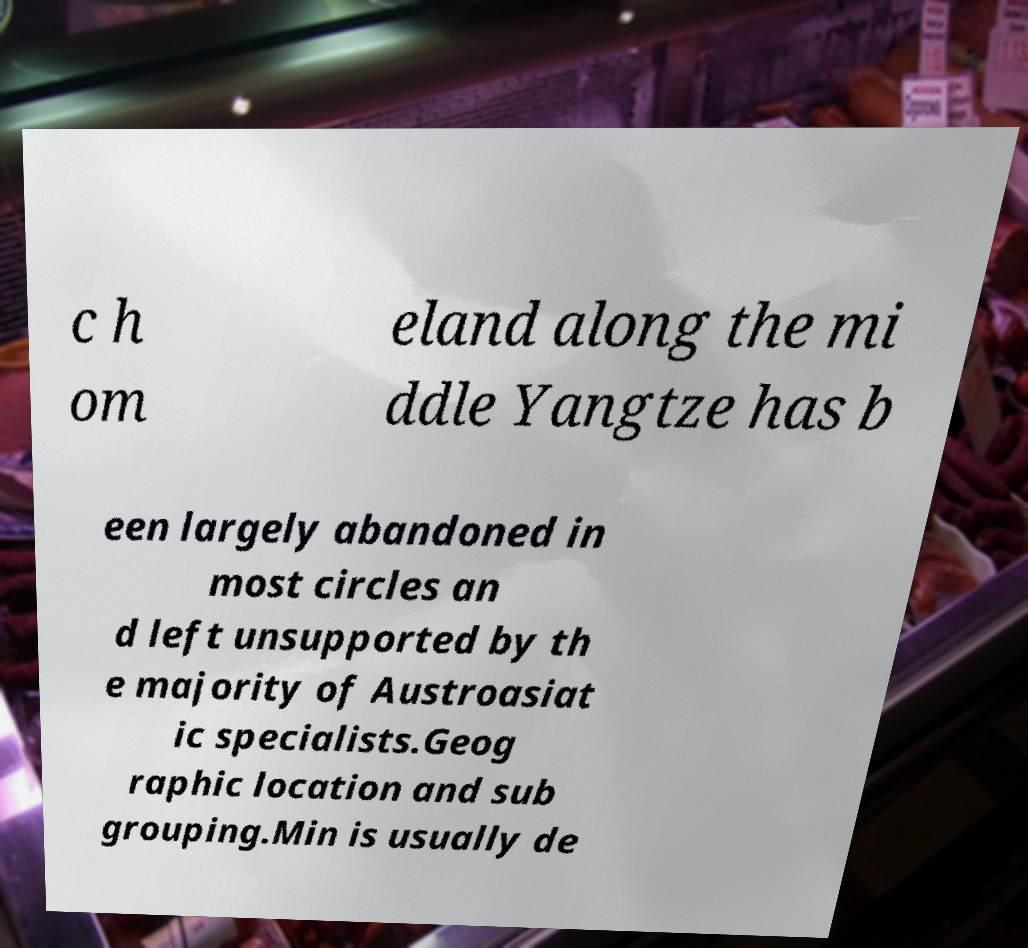Can you read and provide the text displayed in the image?This photo seems to have some interesting text. Can you extract and type it out for me? c h om eland along the mi ddle Yangtze has b een largely abandoned in most circles an d left unsupported by th e majority of Austroasiat ic specialists.Geog raphic location and sub grouping.Min is usually de 